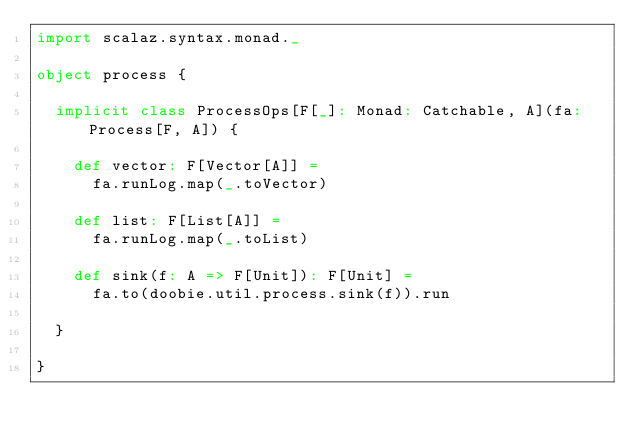Convert code to text. <code><loc_0><loc_0><loc_500><loc_500><_Scala_>import scalaz.syntax.monad._

object process {

  implicit class ProcessOps[F[_]: Monad: Catchable, A](fa: Process[F, A]) {

    def vector: F[Vector[A]] =
      fa.runLog.map(_.toVector)

    def list: F[List[A]] =
      fa.runLog.map(_.toList)

    def sink(f: A => F[Unit]): F[Unit] =     
      fa.to(doobie.util.process.sink(f)).run

  }

}</code> 